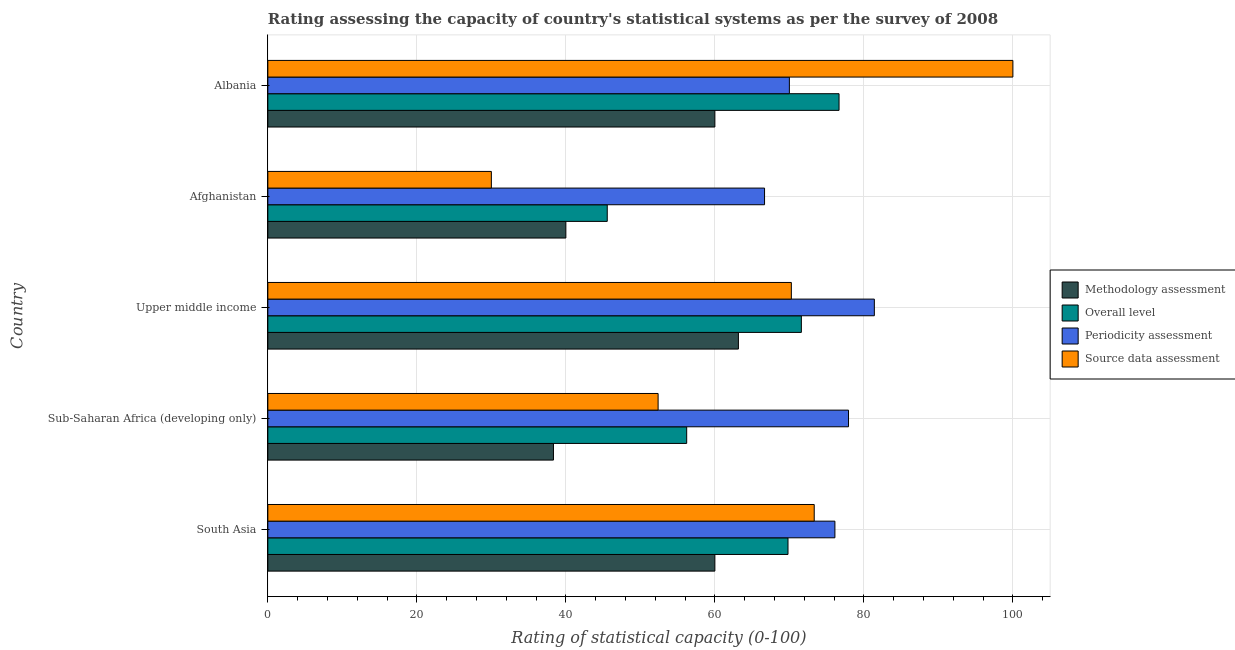Are the number of bars per tick equal to the number of legend labels?
Keep it short and to the point. Yes. How many bars are there on the 2nd tick from the top?
Keep it short and to the point. 4. How many bars are there on the 1st tick from the bottom?
Provide a succinct answer. 4. In how many cases, is the number of bars for a given country not equal to the number of legend labels?
Offer a very short reply. 0. Across all countries, what is the minimum periodicity assessment rating?
Offer a very short reply. 66.67. In which country was the overall level rating maximum?
Offer a very short reply. Albania. In which country was the source data assessment rating minimum?
Provide a succinct answer. Afghanistan. What is the total overall level rating in the graph?
Offer a terse response. 319.86. What is the difference between the overall level rating in Albania and that in Upper middle income?
Your response must be concise. 5.06. What is the difference between the overall level rating in South Asia and the methodology assessment rating in Afghanistan?
Give a very brief answer. 29.81. What is the average overall level rating per country?
Give a very brief answer. 63.97. What is the difference between the source data assessment rating and overall level rating in Afghanistan?
Make the answer very short. -15.56. In how many countries, is the overall level rating greater than 88 ?
Make the answer very short. 0. What is the ratio of the periodicity assessment rating in Albania to that in Upper middle income?
Offer a very short reply. 0.86. Is the source data assessment rating in Afghanistan less than that in Upper middle income?
Offer a terse response. Yes. What is the difference between the highest and the second highest source data assessment rating?
Ensure brevity in your answer.  26.67. What is the difference between the highest and the lowest source data assessment rating?
Offer a very short reply. 70. Is the sum of the periodicity assessment rating in Sub-Saharan Africa (developing only) and Upper middle income greater than the maximum overall level rating across all countries?
Ensure brevity in your answer.  Yes. Is it the case that in every country, the sum of the methodology assessment rating and overall level rating is greater than the sum of source data assessment rating and periodicity assessment rating?
Provide a short and direct response. No. What does the 2nd bar from the top in Afghanistan represents?
Offer a very short reply. Periodicity assessment. What does the 3rd bar from the bottom in Afghanistan represents?
Keep it short and to the point. Periodicity assessment. How many bars are there?
Keep it short and to the point. 20. How many countries are there in the graph?
Provide a short and direct response. 5. Are the values on the major ticks of X-axis written in scientific E-notation?
Give a very brief answer. No. Does the graph contain any zero values?
Give a very brief answer. No. How many legend labels are there?
Ensure brevity in your answer.  4. How are the legend labels stacked?
Your answer should be compact. Vertical. What is the title of the graph?
Give a very brief answer. Rating assessing the capacity of country's statistical systems as per the survey of 2008 . What is the label or title of the X-axis?
Provide a short and direct response. Rating of statistical capacity (0-100). What is the label or title of the Y-axis?
Your answer should be very brief. Country. What is the Rating of statistical capacity (0-100) in Methodology assessment in South Asia?
Provide a short and direct response. 60. What is the Rating of statistical capacity (0-100) of Overall level in South Asia?
Offer a very short reply. 69.81. What is the Rating of statistical capacity (0-100) of Periodicity assessment in South Asia?
Your answer should be compact. 76.11. What is the Rating of statistical capacity (0-100) of Source data assessment in South Asia?
Your answer should be compact. 73.33. What is the Rating of statistical capacity (0-100) in Methodology assessment in Sub-Saharan Africa (developing only)?
Make the answer very short. 38.33. What is the Rating of statistical capacity (0-100) in Overall level in Sub-Saharan Africa (developing only)?
Your answer should be very brief. 56.22. What is the Rating of statistical capacity (0-100) of Periodicity assessment in Sub-Saharan Africa (developing only)?
Your answer should be very brief. 77.94. What is the Rating of statistical capacity (0-100) in Source data assessment in Sub-Saharan Africa (developing only)?
Your answer should be very brief. 52.38. What is the Rating of statistical capacity (0-100) in Methodology assessment in Upper middle income?
Ensure brevity in your answer.  63.16. What is the Rating of statistical capacity (0-100) of Overall level in Upper middle income?
Your response must be concise. 71.61. What is the Rating of statistical capacity (0-100) of Periodicity assessment in Upper middle income?
Make the answer very short. 81.4. What is the Rating of statistical capacity (0-100) of Source data assessment in Upper middle income?
Offer a very short reply. 70.26. What is the Rating of statistical capacity (0-100) of Methodology assessment in Afghanistan?
Keep it short and to the point. 40. What is the Rating of statistical capacity (0-100) of Overall level in Afghanistan?
Offer a terse response. 45.56. What is the Rating of statistical capacity (0-100) of Periodicity assessment in Afghanistan?
Ensure brevity in your answer.  66.67. What is the Rating of statistical capacity (0-100) in Methodology assessment in Albania?
Provide a succinct answer. 60. What is the Rating of statistical capacity (0-100) in Overall level in Albania?
Your response must be concise. 76.67. Across all countries, what is the maximum Rating of statistical capacity (0-100) in Methodology assessment?
Your response must be concise. 63.16. Across all countries, what is the maximum Rating of statistical capacity (0-100) of Overall level?
Your response must be concise. 76.67. Across all countries, what is the maximum Rating of statistical capacity (0-100) of Periodicity assessment?
Your answer should be compact. 81.4. Across all countries, what is the maximum Rating of statistical capacity (0-100) of Source data assessment?
Your response must be concise. 100. Across all countries, what is the minimum Rating of statistical capacity (0-100) of Methodology assessment?
Provide a short and direct response. 38.33. Across all countries, what is the minimum Rating of statistical capacity (0-100) of Overall level?
Offer a very short reply. 45.56. Across all countries, what is the minimum Rating of statistical capacity (0-100) of Periodicity assessment?
Your response must be concise. 66.67. What is the total Rating of statistical capacity (0-100) of Methodology assessment in the graph?
Your answer should be compact. 261.49. What is the total Rating of statistical capacity (0-100) of Overall level in the graph?
Your answer should be very brief. 319.86. What is the total Rating of statistical capacity (0-100) in Periodicity assessment in the graph?
Ensure brevity in your answer.  372.12. What is the total Rating of statistical capacity (0-100) in Source data assessment in the graph?
Keep it short and to the point. 325.98. What is the difference between the Rating of statistical capacity (0-100) in Methodology assessment in South Asia and that in Sub-Saharan Africa (developing only)?
Make the answer very short. 21.67. What is the difference between the Rating of statistical capacity (0-100) of Overall level in South Asia and that in Sub-Saharan Africa (developing only)?
Your answer should be very brief. 13.6. What is the difference between the Rating of statistical capacity (0-100) of Periodicity assessment in South Asia and that in Sub-Saharan Africa (developing only)?
Provide a succinct answer. -1.83. What is the difference between the Rating of statistical capacity (0-100) of Source data assessment in South Asia and that in Sub-Saharan Africa (developing only)?
Give a very brief answer. 20.95. What is the difference between the Rating of statistical capacity (0-100) of Methodology assessment in South Asia and that in Upper middle income?
Your response must be concise. -3.16. What is the difference between the Rating of statistical capacity (0-100) in Overall level in South Asia and that in Upper middle income?
Your answer should be compact. -1.79. What is the difference between the Rating of statistical capacity (0-100) in Periodicity assessment in South Asia and that in Upper middle income?
Give a very brief answer. -5.29. What is the difference between the Rating of statistical capacity (0-100) in Source data assessment in South Asia and that in Upper middle income?
Give a very brief answer. 3.07. What is the difference between the Rating of statistical capacity (0-100) of Methodology assessment in South Asia and that in Afghanistan?
Your answer should be compact. 20. What is the difference between the Rating of statistical capacity (0-100) in Overall level in South Asia and that in Afghanistan?
Keep it short and to the point. 24.26. What is the difference between the Rating of statistical capacity (0-100) of Periodicity assessment in South Asia and that in Afghanistan?
Ensure brevity in your answer.  9.44. What is the difference between the Rating of statistical capacity (0-100) of Source data assessment in South Asia and that in Afghanistan?
Offer a very short reply. 43.33. What is the difference between the Rating of statistical capacity (0-100) of Overall level in South Asia and that in Albania?
Offer a very short reply. -6.85. What is the difference between the Rating of statistical capacity (0-100) of Periodicity assessment in South Asia and that in Albania?
Provide a succinct answer. 6.11. What is the difference between the Rating of statistical capacity (0-100) in Source data assessment in South Asia and that in Albania?
Provide a short and direct response. -26.67. What is the difference between the Rating of statistical capacity (0-100) of Methodology assessment in Sub-Saharan Africa (developing only) and that in Upper middle income?
Ensure brevity in your answer.  -24.82. What is the difference between the Rating of statistical capacity (0-100) of Overall level in Sub-Saharan Africa (developing only) and that in Upper middle income?
Offer a terse response. -15.39. What is the difference between the Rating of statistical capacity (0-100) in Periodicity assessment in Sub-Saharan Africa (developing only) and that in Upper middle income?
Offer a terse response. -3.47. What is the difference between the Rating of statistical capacity (0-100) in Source data assessment in Sub-Saharan Africa (developing only) and that in Upper middle income?
Make the answer very short. -17.88. What is the difference between the Rating of statistical capacity (0-100) of Methodology assessment in Sub-Saharan Africa (developing only) and that in Afghanistan?
Your answer should be very brief. -1.67. What is the difference between the Rating of statistical capacity (0-100) in Overall level in Sub-Saharan Africa (developing only) and that in Afghanistan?
Offer a terse response. 10.66. What is the difference between the Rating of statistical capacity (0-100) in Periodicity assessment in Sub-Saharan Africa (developing only) and that in Afghanistan?
Your answer should be compact. 11.27. What is the difference between the Rating of statistical capacity (0-100) of Source data assessment in Sub-Saharan Africa (developing only) and that in Afghanistan?
Make the answer very short. 22.38. What is the difference between the Rating of statistical capacity (0-100) of Methodology assessment in Sub-Saharan Africa (developing only) and that in Albania?
Give a very brief answer. -21.67. What is the difference between the Rating of statistical capacity (0-100) of Overall level in Sub-Saharan Africa (developing only) and that in Albania?
Make the answer very short. -20.45. What is the difference between the Rating of statistical capacity (0-100) in Periodicity assessment in Sub-Saharan Africa (developing only) and that in Albania?
Keep it short and to the point. 7.94. What is the difference between the Rating of statistical capacity (0-100) in Source data assessment in Sub-Saharan Africa (developing only) and that in Albania?
Give a very brief answer. -47.62. What is the difference between the Rating of statistical capacity (0-100) of Methodology assessment in Upper middle income and that in Afghanistan?
Your answer should be very brief. 23.16. What is the difference between the Rating of statistical capacity (0-100) of Overall level in Upper middle income and that in Afghanistan?
Your answer should be very brief. 26.05. What is the difference between the Rating of statistical capacity (0-100) of Periodicity assessment in Upper middle income and that in Afghanistan?
Offer a very short reply. 14.74. What is the difference between the Rating of statistical capacity (0-100) of Source data assessment in Upper middle income and that in Afghanistan?
Make the answer very short. 40.26. What is the difference between the Rating of statistical capacity (0-100) in Methodology assessment in Upper middle income and that in Albania?
Provide a succinct answer. 3.16. What is the difference between the Rating of statistical capacity (0-100) of Overall level in Upper middle income and that in Albania?
Offer a terse response. -5.06. What is the difference between the Rating of statistical capacity (0-100) of Periodicity assessment in Upper middle income and that in Albania?
Offer a very short reply. 11.4. What is the difference between the Rating of statistical capacity (0-100) of Source data assessment in Upper middle income and that in Albania?
Provide a short and direct response. -29.74. What is the difference between the Rating of statistical capacity (0-100) in Overall level in Afghanistan and that in Albania?
Offer a very short reply. -31.11. What is the difference between the Rating of statistical capacity (0-100) in Periodicity assessment in Afghanistan and that in Albania?
Give a very brief answer. -3.33. What is the difference between the Rating of statistical capacity (0-100) in Source data assessment in Afghanistan and that in Albania?
Make the answer very short. -70. What is the difference between the Rating of statistical capacity (0-100) of Methodology assessment in South Asia and the Rating of statistical capacity (0-100) of Overall level in Sub-Saharan Africa (developing only)?
Your answer should be very brief. 3.78. What is the difference between the Rating of statistical capacity (0-100) of Methodology assessment in South Asia and the Rating of statistical capacity (0-100) of Periodicity assessment in Sub-Saharan Africa (developing only)?
Provide a succinct answer. -17.94. What is the difference between the Rating of statistical capacity (0-100) of Methodology assessment in South Asia and the Rating of statistical capacity (0-100) of Source data assessment in Sub-Saharan Africa (developing only)?
Your answer should be very brief. 7.62. What is the difference between the Rating of statistical capacity (0-100) of Overall level in South Asia and the Rating of statistical capacity (0-100) of Periodicity assessment in Sub-Saharan Africa (developing only)?
Give a very brief answer. -8.12. What is the difference between the Rating of statistical capacity (0-100) of Overall level in South Asia and the Rating of statistical capacity (0-100) of Source data assessment in Sub-Saharan Africa (developing only)?
Make the answer very short. 17.43. What is the difference between the Rating of statistical capacity (0-100) of Periodicity assessment in South Asia and the Rating of statistical capacity (0-100) of Source data assessment in Sub-Saharan Africa (developing only)?
Your response must be concise. 23.73. What is the difference between the Rating of statistical capacity (0-100) of Methodology assessment in South Asia and the Rating of statistical capacity (0-100) of Overall level in Upper middle income?
Provide a short and direct response. -11.61. What is the difference between the Rating of statistical capacity (0-100) of Methodology assessment in South Asia and the Rating of statistical capacity (0-100) of Periodicity assessment in Upper middle income?
Your answer should be compact. -21.4. What is the difference between the Rating of statistical capacity (0-100) of Methodology assessment in South Asia and the Rating of statistical capacity (0-100) of Source data assessment in Upper middle income?
Your answer should be compact. -10.26. What is the difference between the Rating of statistical capacity (0-100) of Overall level in South Asia and the Rating of statistical capacity (0-100) of Periodicity assessment in Upper middle income?
Make the answer very short. -11.59. What is the difference between the Rating of statistical capacity (0-100) in Overall level in South Asia and the Rating of statistical capacity (0-100) in Source data assessment in Upper middle income?
Make the answer very short. -0.45. What is the difference between the Rating of statistical capacity (0-100) of Periodicity assessment in South Asia and the Rating of statistical capacity (0-100) of Source data assessment in Upper middle income?
Provide a short and direct response. 5.85. What is the difference between the Rating of statistical capacity (0-100) in Methodology assessment in South Asia and the Rating of statistical capacity (0-100) in Overall level in Afghanistan?
Your answer should be very brief. 14.44. What is the difference between the Rating of statistical capacity (0-100) in Methodology assessment in South Asia and the Rating of statistical capacity (0-100) in Periodicity assessment in Afghanistan?
Ensure brevity in your answer.  -6.67. What is the difference between the Rating of statistical capacity (0-100) in Overall level in South Asia and the Rating of statistical capacity (0-100) in Periodicity assessment in Afghanistan?
Your answer should be very brief. 3.15. What is the difference between the Rating of statistical capacity (0-100) of Overall level in South Asia and the Rating of statistical capacity (0-100) of Source data assessment in Afghanistan?
Your response must be concise. 39.81. What is the difference between the Rating of statistical capacity (0-100) in Periodicity assessment in South Asia and the Rating of statistical capacity (0-100) in Source data assessment in Afghanistan?
Offer a terse response. 46.11. What is the difference between the Rating of statistical capacity (0-100) in Methodology assessment in South Asia and the Rating of statistical capacity (0-100) in Overall level in Albania?
Ensure brevity in your answer.  -16.67. What is the difference between the Rating of statistical capacity (0-100) of Methodology assessment in South Asia and the Rating of statistical capacity (0-100) of Periodicity assessment in Albania?
Offer a very short reply. -10. What is the difference between the Rating of statistical capacity (0-100) in Methodology assessment in South Asia and the Rating of statistical capacity (0-100) in Source data assessment in Albania?
Make the answer very short. -40. What is the difference between the Rating of statistical capacity (0-100) of Overall level in South Asia and the Rating of statistical capacity (0-100) of Periodicity assessment in Albania?
Provide a short and direct response. -0.19. What is the difference between the Rating of statistical capacity (0-100) in Overall level in South Asia and the Rating of statistical capacity (0-100) in Source data assessment in Albania?
Your answer should be compact. -30.19. What is the difference between the Rating of statistical capacity (0-100) of Periodicity assessment in South Asia and the Rating of statistical capacity (0-100) of Source data assessment in Albania?
Provide a succinct answer. -23.89. What is the difference between the Rating of statistical capacity (0-100) of Methodology assessment in Sub-Saharan Africa (developing only) and the Rating of statistical capacity (0-100) of Overall level in Upper middle income?
Give a very brief answer. -33.27. What is the difference between the Rating of statistical capacity (0-100) of Methodology assessment in Sub-Saharan Africa (developing only) and the Rating of statistical capacity (0-100) of Periodicity assessment in Upper middle income?
Offer a very short reply. -43.07. What is the difference between the Rating of statistical capacity (0-100) in Methodology assessment in Sub-Saharan Africa (developing only) and the Rating of statistical capacity (0-100) in Source data assessment in Upper middle income?
Offer a very short reply. -31.93. What is the difference between the Rating of statistical capacity (0-100) of Overall level in Sub-Saharan Africa (developing only) and the Rating of statistical capacity (0-100) of Periodicity assessment in Upper middle income?
Your answer should be very brief. -25.19. What is the difference between the Rating of statistical capacity (0-100) in Overall level in Sub-Saharan Africa (developing only) and the Rating of statistical capacity (0-100) in Source data assessment in Upper middle income?
Ensure brevity in your answer.  -14.05. What is the difference between the Rating of statistical capacity (0-100) in Periodicity assessment in Sub-Saharan Africa (developing only) and the Rating of statistical capacity (0-100) in Source data assessment in Upper middle income?
Provide a succinct answer. 7.67. What is the difference between the Rating of statistical capacity (0-100) in Methodology assessment in Sub-Saharan Africa (developing only) and the Rating of statistical capacity (0-100) in Overall level in Afghanistan?
Keep it short and to the point. -7.22. What is the difference between the Rating of statistical capacity (0-100) of Methodology assessment in Sub-Saharan Africa (developing only) and the Rating of statistical capacity (0-100) of Periodicity assessment in Afghanistan?
Ensure brevity in your answer.  -28.33. What is the difference between the Rating of statistical capacity (0-100) in Methodology assessment in Sub-Saharan Africa (developing only) and the Rating of statistical capacity (0-100) in Source data assessment in Afghanistan?
Offer a very short reply. 8.33. What is the difference between the Rating of statistical capacity (0-100) of Overall level in Sub-Saharan Africa (developing only) and the Rating of statistical capacity (0-100) of Periodicity assessment in Afghanistan?
Keep it short and to the point. -10.45. What is the difference between the Rating of statistical capacity (0-100) of Overall level in Sub-Saharan Africa (developing only) and the Rating of statistical capacity (0-100) of Source data assessment in Afghanistan?
Keep it short and to the point. 26.22. What is the difference between the Rating of statistical capacity (0-100) in Periodicity assessment in Sub-Saharan Africa (developing only) and the Rating of statistical capacity (0-100) in Source data assessment in Afghanistan?
Provide a short and direct response. 47.94. What is the difference between the Rating of statistical capacity (0-100) in Methodology assessment in Sub-Saharan Africa (developing only) and the Rating of statistical capacity (0-100) in Overall level in Albania?
Your answer should be compact. -38.33. What is the difference between the Rating of statistical capacity (0-100) in Methodology assessment in Sub-Saharan Africa (developing only) and the Rating of statistical capacity (0-100) in Periodicity assessment in Albania?
Ensure brevity in your answer.  -31.67. What is the difference between the Rating of statistical capacity (0-100) in Methodology assessment in Sub-Saharan Africa (developing only) and the Rating of statistical capacity (0-100) in Source data assessment in Albania?
Keep it short and to the point. -61.67. What is the difference between the Rating of statistical capacity (0-100) in Overall level in Sub-Saharan Africa (developing only) and the Rating of statistical capacity (0-100) in Periodicity assessment in Albania?
Provide a succinct answer. -13.78. What is the difference between the Rating of statistical capacity (0-100) in Overall level in Sub-Saharan Africa (developing only) and the Rating of statistical capacity (0-100) in Source data assessment in Albania?
Your response must be concise. -43.78. What is the difference between the Rating of statistical capacity (0-100) in Periodicity assessment in Sub-Saharan Africa (developing only) and the Rating of statistical capacity (0-100) in Source data assessment in Albania?
Provide a succinct answer. -22.06. What is the difference between the Rating of statistical capacity (0-100) in Methodology assessment in Upper middle income and the Rating of statistical capacity (0-100) in Overall level in Afghanistan?
Your answer should be compact. 17.6. What is the difference between the Rating of statistical capacity (0-100) in Methodology assessment in Upper middle income and the Rating of statistical capacity (0-100) in Periodicity assessment in Afghanistan?
Make the answer very short. -3.51. What is the difference between the Rating of statistical capacity (0-100) in Methodology assessment in Upper middle income and the Rating of statistical capacity (0-100) in Source data assessment in Afghanistan?
Give a very brief answer. 33.16. What is the difference between the Rating of statistical capacity (0-100) of Overall level in Upper middle income and the Rating of statistical capacity (0-100) of Periodicity assessment in Afghanistan?
Ensure brevity in your answer.  4.94. What is the difference between the Rating of statistical capacity (0-100) of Overall level in Upper middle income and the Rating of statistical capacity (0-100) of Source data assessment in Afghanistan?
Your answer should be compact. 41.61. What is the difference between the Rating of statistical capacity (0-100) in Periodicity assessment in Upper middle income and the Rating of statistical capacity (0-100) in Source data assessment in Afghanistan?
Your answer should be very brief. 51.4. What is the difference between the Rating of statistical capacity (0-100) of Methodology assessment in Upper middle income and the Rating of statistical capacity (0-100) of Overall level in Albania?
Ensure brevity in your answer.  -13.51. What is the difference between the Rating of statistical capacity (0-100) of Methodology assessment in Upper middle income and the Rating of statistical capacity (0-100) of Periodicity assessment in Albania?
Offer a terse response. -6.84. What is the difference between the Rating of statistical capacity (0-100) of Methodology assessment in Upper middle income and the Rating of statistical capacity (0-100) of Source data assessment in Albania?
Your answer should be very brief. -36.84. What is the difference between the Rating of statistical capacity (0-100) in Overall level in Upper middle income and the Rating of statistical capacity (0-100) in Periodicity assessment in Albania?
Offer a very short reply. 1.61. What is the difference between the Rating of statistical capacity (0-100) of Overall level in Upper middle income and the Rating of statistical capacity (0-100) of Source data assessment in Albania?
Make the answer very short. -28.39. What is the difference between the Rating of statistical capacity (0-100) in Periodicity assessment in Upper middle income and the Rating of statistical capacity (0-100) in Source data assessment in Albania?
Your response must be concise. -18.6. What is the difference between the Rating of statistical capacity (0-100) of Methodology assessment in Afghanistan and the Rating of statistical capacity (0-100) of Overall level in Albania?
Give a very brief answer. -36.67. What is the difference between the Rating of statistical capacity (0-100) of Methodology assessment in Afghanistan and the Rating of statistical capacity (0-100) of Source data assessment in Albania?
Offer a terse response. -60. What is the difference between the Rating of statistical capacity (0-100) in Overall level in Afghanistan and the Rating of statistical capacity (0-100) in Periodicity assessment in Albania?
Provide a short and direct response. -24.44. What is the difference between the Rating of statistical capacity (0-100) of Overall level in Afghanistan and the Rating of statistical capacity (0-100) of Source data assessment in Albania?
Your answer should be very brief. -54.44. What is the difference between the Rating of statistical capacity (0-100) of Periodicity assessment in Afghanistan and the Rating of statistical capacity (0-100) of Source data assessment in Albania?
Keep it short and to the point. -33.33. What is the average Rating of statistical capacity (0-100) of Methodology assessment per country?
Keep it short and to the point. 52.3. What is the average Rating of statistical capacity (0-100) in Overall level per country?
Make the answer very short. 63.97. What is the average Rating of statistical capacity (0-100) of Periodicity assessment per country?
Give a very brief answer. 74.42. What is the average Rating of statistical capacity (0-100) of Source data assessment per country?
Offer a terse response. 65.2. What is the difference between the Rating of statistical capacity (0-100) in Methodology assessment and Rating of statistical capacity (0-100) in Overall level in South Asia?
Offer a terse response. -9.81. What is the difference between the Rating of statistical capacity (0-100) in Methodology assessment and Rating of statistical capacity (0-100) in Periodicity assessment in South Asia?
Keep it short and to the point. -16.11. What is the difference between the Rating of statistical capacity (0-100) in Methodology assessment and Rating of statistical capacity (0-100) in Source data assessment in South Asia?
Ensure brevity in your answer.  -13.33. What is the difference between the Rating of statistical capacity (0-100) in Overall level and Rating of statistical capacity (0-100) in Periodicity assessment in South Asia?
Your answer should be compact. -6.3. What is the difference between the Rating of statistical capacity (0-100) in Overall level and Rating of statistical capacity (0-100) in Source data assessment in South Asia?
Make the answer very short. -3.52. What is the difference between the Rating of statistical capacity (0-100) of Periodicity assessment and Rating of statistical capacity (0-100) of Source data assessment in South Asia?
Your answer should be compact. 2.78. What is the difference between the Rating of statistical capacity (0-100) in Methodology assessment and Rating of statistical capacity (0-100) in Overall level in Sub-Saharan Africa (developing only)?
Your answer should be very brief. -17.88. What is the difference between the Rating of statistical capacity (0-100) in Methodology assessment and Rating of statistical capacity (0-100) in Periodicity assessment in Sub-Saharan Africa (developing only)?
Your answer should be compact. -39.6. What is the difference between the Rating of statistical capacity (0-100) of Methodology assessment and Rating of statistical capacity (0-100) of Source data assessment in Sub-Saharan Africa (developing only)?
Your answer should be very brief. -14.05. What is the difference between the Rating of statistical capacity (0-100) in Overall level and Rating of statistical capacity (0-100) in Periodicity assessment in Sub-Saharan Africa (developing only)?
Offer a terse response. -21.72. What is the difference between the Rating of statistical capacity (0-100) in Overall level and Rating of statistical capacity (0-100) in Source data assessment in Sub-Saharan Africa (developing only)?
Your response must be concise. 3.84. What is the difference between the Rating of statistical capacity (0-100) in Periodicity assessment and Rating of statistical capacity (0-100) in Source data assessment in Sub-Saharan Africa (developing only)?
Offer a very short reply. 25.56. What is the difference between the Rating of statistical capacity (0-100) of Methodology assessment and Rating of statistical capacity (0-100) of Overall level in Upper middle income?
Offer a very short reply. -8.45. What is the difference between the Rating of statistical capacity (0-100) in Methodology assessment and Rating of statistical capacity (0-100) in Periodicity assessment in Upper middle income?
Give a very brief answer. -18.25. What is the difference between the Rating of statistical capacity (0-100) of Methodology assessment and Rating of statistical capacity (0-100) of Source data assessment in Upper middle income?
Offer a very short reply. -7.11. What is the difference between the Rating of statistical capacity (0-100) in Overall level and Rating of statistical capacity (0-100) in Periodicity assessment in Upper middle income?
Provide a short and direct response. -9.8. What is the difference between the Rating of statistical capacity (0-100) of Overall level and Rating of statistical capacity (0-100) of Source data assessment in Upper middle income?
Your answer should be very brief. 1.34. What is the difference between the Rating of statistical capacity (0-100) in Periodicity assessment and Rating of statistical capacity (0-100) in Source data assessment in Upper middle income?
Make the answer very short. 11.14. What is the difference between the Rating of statistical capacity (0-100) of Methodology assessment and Rating of statistical capacity (0-100) of Overall level in Afghanistan?
Keep it short and to the point. -5.56. What is the difference between the Rating of statistical capacity (0-100) of Methodology assessment and Rating of statistical capacity (0-100) of Periodicity assessment in Afghanistan?
Give a very brief answer. -26.67. What is the difference between the Rating of statistical capacity (0-100) in Methodology assessment and Rating of statistical capacity (0-100) in Source data assessment in Afghanistan?
Ensure brevity in your answer.  10. What is the difference between the Rating of statistical capacity (0-100) in Overall level and Rating of statistical capacity (0-100) in Periodicity assessment in Afghanistan?
Give a very brief answer. -21.11. What is the difference between the Rating of statistical capacity (0-100) in Overall level and Rating of statistical capacity (0-100) in Source data assessment in Afghanistan?
Your response must be concise. 15.56. What is the difference between the Rating of statistical capacity (0-100) in Periodicity assessment and Rating of statistical capacity (0-100) in Source data assessment in Afghanistan?
Offer a very short reply. 36.67. What is the difference between the Rating of statistical capacity (0-100) in Methodology assessment and Rating of statistical capacity (0-100) in Overall level in Albania?
Keep it short and to the point. -16.67. What is the difference between the Rating of statistical capacity (0-100) of Methodology assessment and Rating of statistical capacity (0-100) of Periodicity assessment in Albania?
Provide a short and direct response. -10. What is the difference between the Rating of statistical capacity (0-100) of Methodology assessment and Rating of statistical capacity (0-100) of Source data assessment in Albania?
Your response must be concise. -40. What is the difference between the Rating of statistical capacity (0-100) in Overall level and Rating of statistical capacity (0-100) in Periodicity assessment in Albania?
Ensure brevity in your answer.  6.67. What is the difference between the Rating of statistical capacity (0-100) in Overall level and Rating of statistical capacity (0-100) in Source data assessment in Albania?
Ensure brevity in your answer.  -23.33. What is the difference between the Rating of statistical capacity (0-100) of Periodicity assessment and Rating of statistical capacity (0-100) of Source data assessment in Albania?
Provide a succinct answer. -30. What is the ratio of the Rating of statistical capacity (0-100) in Methodology assessment in South Asia to that in Sub-Saharan Africa (developing only)?
Your answer should be compact. 1.57. What is the ratio of the Rating of statistical capacity (0-100) of Overall level in South Asia to that in Sub-Saharan Africa (developing only)?
Provide a succinct answer. 1.24. What is the ratio of the Rating of statistical capacity (0-100) of Periodicity assessment in South Asia to that in Sub-Saharan Africa (developing only)?
Your answer should be very brief. 0.98. What is the ratio of the Rating of statistical capacity (0-100) of Methodology assessment in South Asia to that in Upper middle income?
Offer a terse response. 0.95. What is the ratio of the Rating of statistical capacity (0-100) of Overall level in South Asia to that in Upper middle income?
Offer a very short reply. 0.97. What is the ratio of the Rating of statistical capacity (0-100) in Periodicity assessment in South Asia to that in Upper middle income?
Your answer should be compact. 0.94. What is the ratio of the Rating of statistical capacity (0-100) of Source data assessment in South Asia to that in Upper middle income?
Your answer should be compact. 1.04. What is the ratio of the Rating of statistical capacity (0-100) of Overall level in South Asia to that in Afghanistan?
Offer a very short reply. 1.53. What is the ratio of the Rating of statistical capacity (0-100) in Periodicity assessment in South Asia to that in Afghanistan?
Ensure brevity in your answer.  1.14. What is the ratio of the Rating of statistical capacity (0-100) of Source data assessment in South Asia to that in Afghanistan?
Your answer should be very brief. 2.44. What is the ratio of the Rating of statistical capacity (0-100) of Methodology assessment in South Asia to that in Albania?
Offer a terse response. 1. What is the ratio of the Rating of statistical capacity (0-100) in Overall level in South Asia to that in Albania?
Ensure brevity in your answer.  0.91. What is the ratio of the Rating of statistical capacity (0-100) of Periodicity assessment in South Asia to that in Albania?
Give a very brief answer. 1.09. What is the ratio of the Rating of statistical capacity (0-100) of Source data assessment in South Asia to that in Albania?
Give a very brief answer. 0.73. What is the ratio of the Rating of statistical capacity (0-100) in Methodology assessment in Sub-Saharan Africa (developing only) to that in Upper middle income?
Your response must be concise. 0.61. What is the ratio of the Rating of statistical capacity (0-100) of Overall level in Sub-Saharan Africa (developing only) to that in Upper middle income?
Give a very brief answer. 0.79. What is the ratio of the Rating of statistical capacity (0-100) in Periodicity assessment in Sub-Saharan Africa (developing only) to that in Upper middle income?
Provide a short and direct response. 0.96. What is the ratio of the Rating of statistical capacity (0-100) in Source data assessment in Sub-Saharan Africa (developing only) to that in Upper middle income?
Your answer should be very brief. 0.75. What is the ratio of the Rating of statistical capacity (0-100) of Methodology assessment in Sub-Saharan Africa (developing only) to that in Afghanistan?
Your answer should be compact. 0.96. What is the ratio of the Rating of statistical capacity (0-100) of Overall level in Sub-Saharan Africa (developing only) to that in Afghanistan?
Make the answer very short. 1.23. What is the ratio of the Rating of statistical capacity (0-100) of Periodicity assessment in Sub-Saharan Africa (developing only) to that in Afghanistan?
Make the answer very short. 1.17. What is the ratio of the Rating of statistical capacity (0-100) in Source data assessment in Sub-Saharan Africa (developing only) to that in Afghanistan?
Your answer should be very brief. 1.75. What is the ratio of the Rating of statistical capacity (0-100) of Methodology assessment in Sub-Saharan Africa (developing only) to that in Albania?
Provide a short and direct response. 0.64. What is the ratio of the Rating of statistical capacity (0-100) in Overall level in Sub-Saharan Africa (developing only) to that in Albania?
Your answer should be very brief. 0.73. What is the ratio of the Rating of statistical capacity (0-100) in Periodicity assessment in Sub-Saharan Africa (developing only) to that in Albania?
Your answer should be very brief. 1.11. What is the ratio of the Rating of statistical capacity (0-100) in Source data assessment in Sub-Saharan Africa (developing only) to that in Albania?
Your answer should be compact. 0.52. What is the ratio of the Rating of statistical capacity (0-100) in Methodology assessment in Upper middle income to that in Afghanistan?
Provide a short and direct response. 1.58. What is the ratio of the Rating of statistical capacity (0-100) in Overall level in Upper middle income to that in Afghanistan?
Your answer should be compact. 1.57. What is the ratio of the Rating of statistical capacity (0-100) in Periodicity assessment in Upper middle income to that in Afghanistan?
Your answer should be compact. 1.22. What is the ratio of the Rating of statistical capacity (0-100) in Source data assessment in Upper middle income to that in Afghanistan?
Your response must be concise. 2.34. What is the ratio of the Rating of statistical capacity (0-100) in Methodology assessment in Upper middle income to that in Albania?
Keep it short and to the point. 1.05. What is the ratio of the Rating of statistical capacity (0-100) in Overall level in Upper middle income to that in Albania?
Your answer should be very brief. 0.93. What is the ratio of the Rating of statistical capacity (0-100) of Periodicity assessment in Upper middle income to that in Albania?
Your answer should be very brief. 1.16. What is the ratio of the Rating of statistical capacity (0-100) of Source data assessment in Upper middle income to that in Albania?
Ensure brevity in your answer.  0.7. What is the ratio of the Rating of statistical capacity (0-100) in Overall level in Afghanistan to that in Albania?
Offer a very short reply. 0.59. What is the ratio of the Rating of statistical capacity (0-100) in Source data assessment in Afghanistan to that in Albania?
Your answer should be compact. 0.3. What is the difference between the highest and the second highest Rating of statistical capacity (0-100) in Methodology assessment?
Offer a terse response. 3.16. What is the difference between the highest and the second highest Rating of statistical capacity (0-100) in Overall level?
Keep it short and to the point. 5.06. What is the difference between the highest and the second highest Rating of statistical capacity (0-100) of Periodicity assessment?
Provide a short and direct response. 3.47. What is the difference between the highest and the second highest Rating of statistical capacity (0-100) in Source data assessment?
Make the answer very short. 26.67. What is the difference between the highest and the lowest Rating of statistical capacity (0-100) in Methodology assessment?
Keep it short and to the point. 24.82. What is the difference between the highest and the lowest Rating of statistical capacity (0-100) of Overall level?
Make the answer very short. 31.11. What is the difference between the highest and the lowest Rating of statistical capacity (0-100) of Periodicity assessment?
Make the answer very short. 14.74. What is the difference between the highest and the lowest Rating of statistical capacity (0-100) in Source data assessment?
Your answer should be compact. 70. 